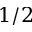Convert formula to latex. <formula><loc_0><loc_0><loc_500><loc_500>1 / 2</formula> 